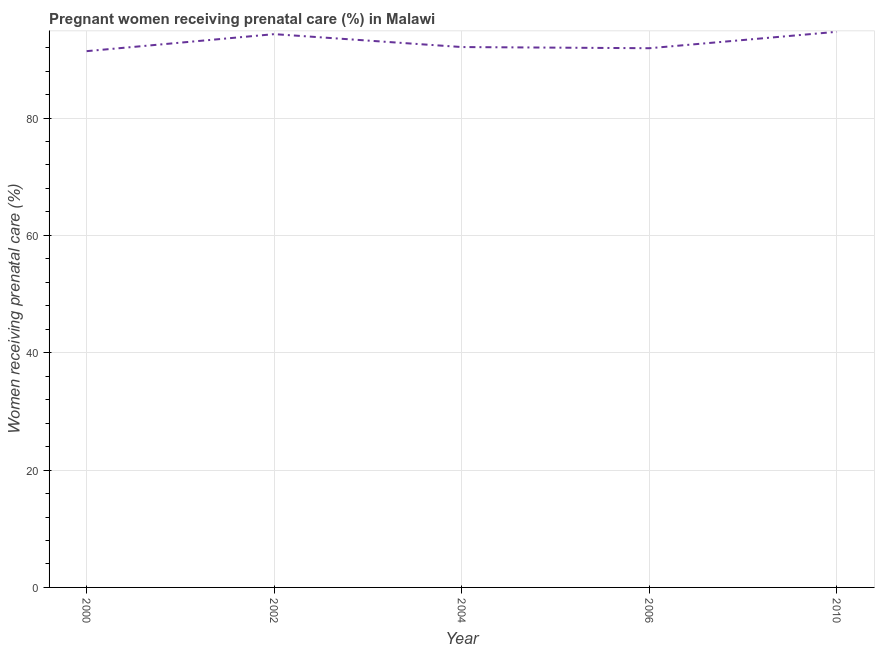What is the percentage of pregnant women receiving prenatal care in 2002?
Provide a short and direct response. 94.3. Across all years, what is the maximum percentage of pregnant women receiving prenatal care?
Ensure brevity in your answer.  94.7. Across all years, what is the minimum percentage of pregnant women receiving prenatal care?
Offer a very short reply. 91.4. In which year was the percentage of pregnant women receiving prenatal care maximum?
Give a very brief answer. 2010. In which year was the percentage of pregnant women receiving prenatal care minimum?
Give a very brief answer. 2000. What is the sum of the percentage of pregnant women receiving prenatal care?
Give a very brief answer. 464.4. What is the difference between the percentage of pregnant women receiving prenatal care in 2004 and 2010?
Ensure brevity in your answer.  -2.6. What is the average percentage of pregnant women receiving prenatal care per year?
Provide a short and direct response. 92.88. What is the median percentage of pregnant women receiving prenatal care?
Provide a short and direct response. 92.1. In how many years, is the percentage of pregnant women receiving prenatal care greater than 60 %?
Provide a short and direct response. 5. Do a majority of the years between 2000 and 2002 (inclusive) have percentage of pregnant women receiving prenatal care greater than 76 %?
Ensure brevity in your answer.  Yes. What is the ratio of the percentage of pregnant women receiving prenatal care in 2004 to that in 2006?
Give a very brief answer. 1. What is the difference between the highest and the second highest percentage of pregnant women receiving prenatal care?
Provide a succinct answer. 0.4. Is the sum of the percentage of pregnant women receiving prenatal care in 2000 and 2002 greater than the maximum percentage of pregnant women receiving prenatal care across all years?
Give a very brief answer. Yes. What is the difference between the highest and the lowest percentage of pregnant women receiving prenatal care?
Your answer should be very brief. 3.3. In how many years, is the percentage of pregnant women receiving prenatal care greater than the average percentage of pregnant women receiving prenatal care taken over all years?
Keep it short and to the point. 2. What is the difference between two consecutive major ticks on the Y-axis?
Keep it short and to the point. 20. What is the title of the graph?
Give a very brief answer. Pregnant women receiving prenatal care (%) in Malawi. What is the label or title of the Y-axis?
Your answer should be compact. Women receiving prenatal care (%). What is the Women receiving prenatal care (%) in 2000?
Your answer should be compact. 91.4. What is the Women receiving prenatal care (%) in 2002?
Give a very brief answer. 94.3. What is the Women receiving prenatal care (%) of 2004?
Ensure brevity in your answer.  92.1. What is the Women receiving prenatal care (%) of 2006?
Provide a succinct answer. 91.9. What is the Women receiving prenatal care (%) of 2010?
Keep it short and to the point. 94.7. What is the difference between the Women receiving prenatal care (%) in 2000 and 2006?
Provide a short and direct response. -0.5. What is the difference between the Women receiving prenatal care (%) in 2002 and 2006?
Offer a very short reply. 2.4. What is the difference between the Women receiving prenatal care (%) in 2004 and 2006?
Your response must be concise. 0.2. What is the ratio of the Women receiving prenatal care (%) in 2000 to that in 2002?
Your answer should be compact. 0.97. What is the ratio of the Women receiving prenatal care (%) in 2000 to that in 2004?
Ensure brevity in your answer.  0.99. What is the ratio of the Women receiving prenatal care (%) in 2000 to that in 2006?
Provide a succinct answer. 0.99. What is the ratio of the Women receiving prenatal care (%) in 2000 to that in 2010?
Provide a short and direct response. 0.96. What is the ratio of the Women receiving prenatal care (%) in 2002 to that in 2004?
Provide a short and direct response. 1.02. What is the ratio of the Women receiving prenatal care (%) in 2004 to that in 2010?
Provide a succinct answer. 0.97. 